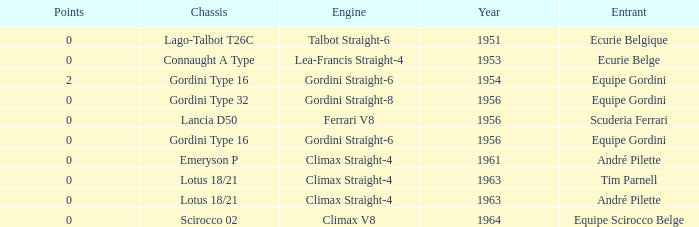Who used Gordini Straight-6 in 1956? Equipe Gordini. 